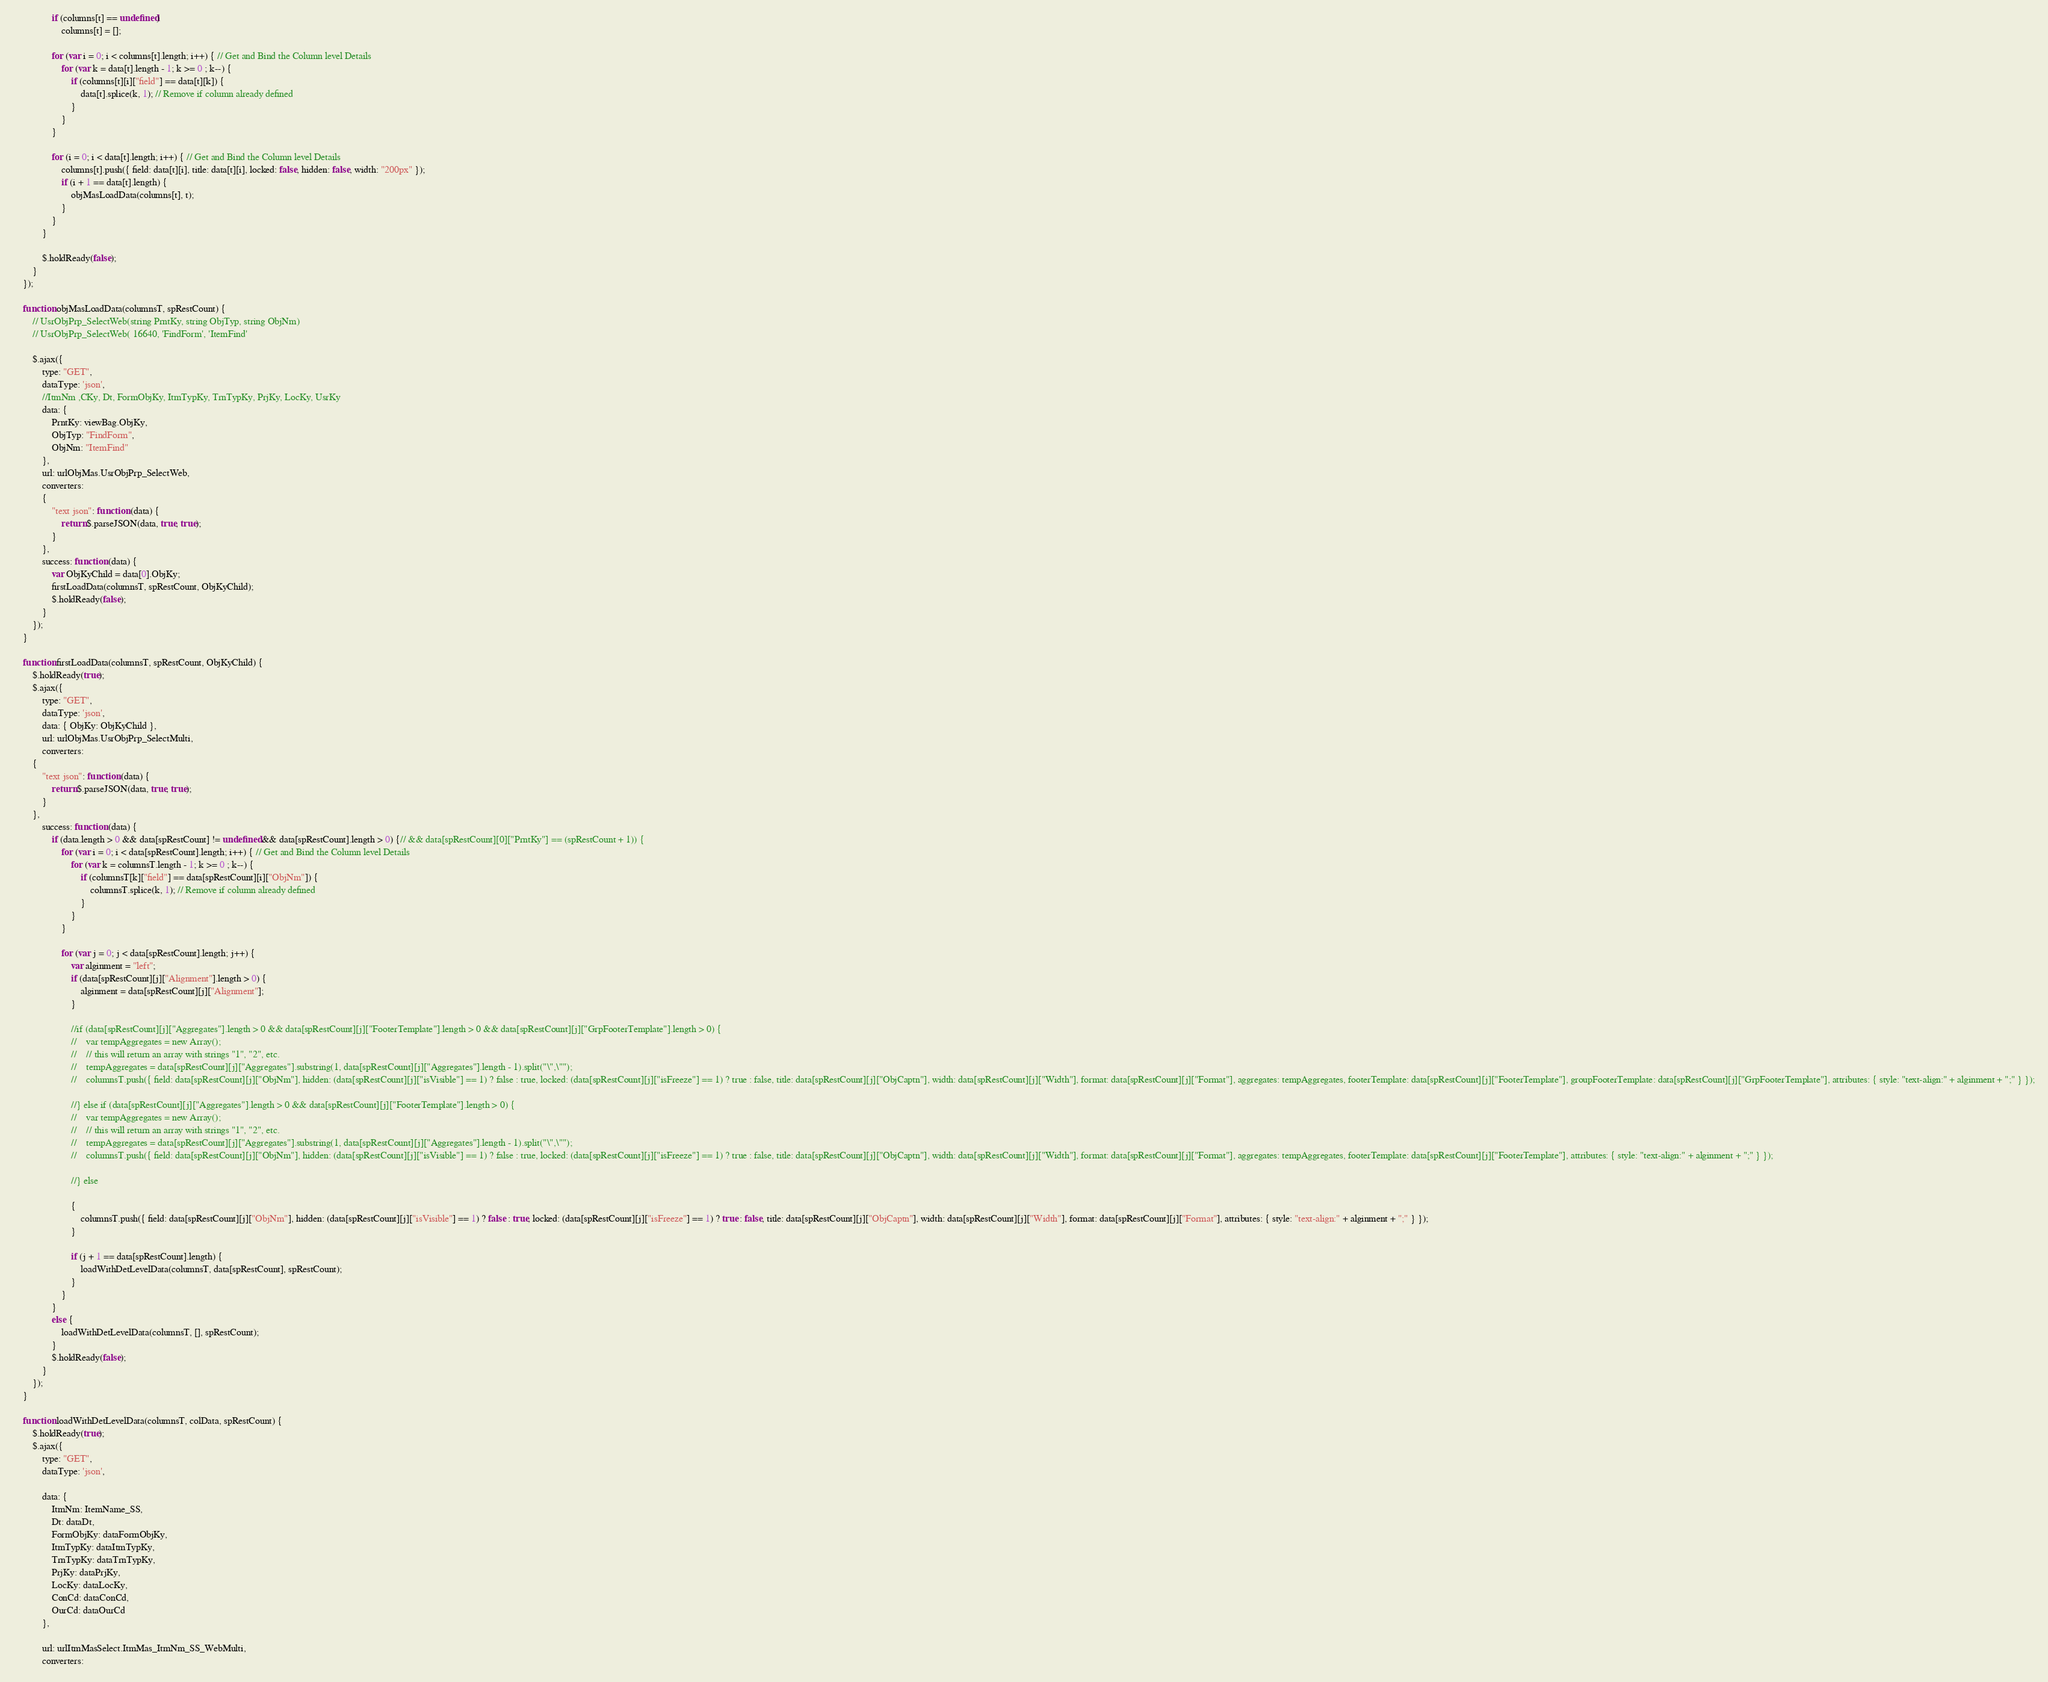<code> <loc_0><loc_0><loc_500><loc_500><_JavaScript_>
                if (columns[t] == undefined)
                    columns[t] = [];

                for (var i = 0; i < columns[t].length; i++) { // Get and Bind the Column level Details
                    for (var k = data[t].length - 1; k >= 0 ; k--) {
                        if (columns[t][i]["field"] == data[t][k]) {
                            data[t].splice(k, 1); // Remove if column already defined
                        }
                    }
                }

                for (i = 0; i < data[t].length; i++) { // Get and Bind the Column level Details
                    columns[t].push({ field: data[t][i], title: data[t][i], locked: false, hidden: false, width: "200px" });
                    if (i + 1 == data[t].length) {
                        objMasLoadData(columns[t], t);
                    }
                }
            }

            $.holdReady(false);
        }
    });

    function objMasLoadData(columnsT, spRestCount) {
        // UsrObjPrp_SelectWeb(string PrntKy, string ObjTyp, string ObjNm)
        // UsrObjPrp_SelectWeb( 16640, 'FindForm', 'ItemFind'

        $.ajax({
            type: "GET",
            dataType: 'json',
            //ItmNm ,CKy, Dt, FormObjKy, ItmTypKy, TrnTypKy, PrjKy, LocKy, UsrKy
            data: {
                PrntKy: viewBag.ObjKy,
                ObjTyp: "FindForm",
                ObjNm: "ItemFind"
            },
            url: urlObjMas.UsrObjPrp_SelectWeb,
            converters:
            {
                "text json": function (data) {
                    return $.parseJSON(data, true, true);
                }
            },
            success: function (data) {
                var ObjKyChild = data[0].ObjKy;
                firstLoadData(columnsT, spRestCount, ObjKyChild);
                $.holdReady(false);
            }
        });
    }

    function firstLoadData(columnsT, spRestCount, ObjKyChild) {
        $.holdReady(true);
        $.ajax({
            type: "GET",
            dataType: 'json',
            data: { ObjKy: ObjKyChild },
            url: urlObjMas.UsrObjPrp_SelectMulti,
            converters:
        {
            "text json": function (data) {
                return $.parseJSON(data, true, true);
            }
        },
            success: function (data) {
                if (data.length > 0 && data[spRestCount] != undefined && data[spRestCount].length > 0) {// && data[spRestCount][0]["PrntKy"] == (spRestCount + 1)) {
                    for (var i = 0; i < data[spRestCount].length; i++) { // Get and Bind the Column level Details
                        for (var k = columnsT.length - 1; k >= 0 ; k--) {
                            if (columnsT[k]["field"] == data[spRestCount][i]["ObjNm"]) {
                                columnsT.splice(k, 1); // Remove if column already defined
                            }
                        }
                    }

                    for (var j = 0; j < data[spRestCount].length; j++) {
                        var alginment = "left";
                        if (data[spRestCount][j]["Alignment"].length > 0) {
                            alginment = data[spRestCount][j]["Alignment"];
                        }

                        //if (data[spRestCount][j]["Aggregates"].length > 0 && data[spRestCount][j]["FooterTemplate"].length > 0 && data[spRestCount][j]["GrpFooterTemplate"].length > 0) {
                        //    var tempAggregates = new Array();
                        //    // this will return an array with strings "1", "2", etc.
                        //    tempAggregates = data[spRestCount][j]["Aggregates"].substring(1, data[spRestCount][j]["Aggregates"].length - 1).split("\",\"");
                        //    columnsT.push({ field: data[spRestCount][j]["ObjNm"], hidden: (data[spRestCount][j]["isVisible"] == 1) ? false : true, locked: (data[spRestCount][j]["isFreeze"] == 1) ? true : false, title: data[spRestCount][j]["ObjCaptn"], width: data[spRestCount][j]["Width"], format: data[spRestCount][j]["Format"], aggregates: tempAggregates, footerTemplate: data[spRestCount][j]["FooterTemplate"], groupFooterTemplate: data[spRestCount][j]["GrpFooterTemplate"], attributes: { style: "text-align:" + alginment + ";" } });

                        //} else if (data[spRestCount][j]["Aggregates"].length > 0 && data[spRestCount][j]["FooterTemplate"].length > 0) {
                        //    var tempAggregates = new Array();
                        //    // this will return an array with strings "1", "2", etc.
                        //    tempAggregates = data[spRestCount][j]["Aggregates"].substring(1, data[spRestCount][j]["Aggregates"].length - 1).split("\",\"");
                        //    columnsT.push({ field: data[spRestCount][j]["ObjNm"], hidden: (data[spRestCount][j]["isVisible"] == 1) ? false : true, locked: (data[spRestCount][j]["isFreeze"] == 1) ? true : false, title: data[spRestCount][j]["ObjCaptn"], width: data[spRestCount][j]["Width"], format: data[spRestCount][j]["Format"], aggregates: tempAggregates, footerTemplate: data[spRestCount][j]["FooterTemplate"], attributes: { style: "text-align:" + alginment + ";" } });

                        //} else

                        {
                            columnsT.push({ field: data[spRestCount][j]["ObjNm"], hidden: (data[spRestCount][j]["isVisible"] == 1) ? false : true, locked: (data[spRestCount][j]["isFreeze"] == 1) ? true : false, title: data[spRestCount][j]["ObjCaptn"], width: data[spRestCount][j]["Width"], format: data[spRestCount][j]["Format"], attributes: { style: "text-align:" + alginment + ";" } });
                        }

                        if (j + 1 == data[spRestCount].length) {
                            loadWithDetLevelData(columnsT, data[spRestCount], spRestCount);
                        }
                    }
                }
                else {
                    loadWithDetLevelData(columnsT, [], spRestCount);
                }
                $.holdReady(false);
            }
        });
    }

    function loadWithDetLevelData(columnsT, colData, spRestCount) {
        $.holdReady(true);
        $.ajax({
            type: "GET",
            dataType: 'json',

            data: {
                ItmNm: ItemName_SS,
                Dt: dataDt,
                FormObjKy: dataFormObjKy,
                ItmTypKy: dataItmTypKy,
                TrnTypKy: dataTrnTypKy,
                PrjKy: dataPrjKy,
                LocKy: dataLocKy,
                ConCd: dataConCd,
                OurCd: dataOurCd
            },

            url: urlItmMasSelect.ItmMas_ItmNm_SS_WebMulti,
            converters:</code> 